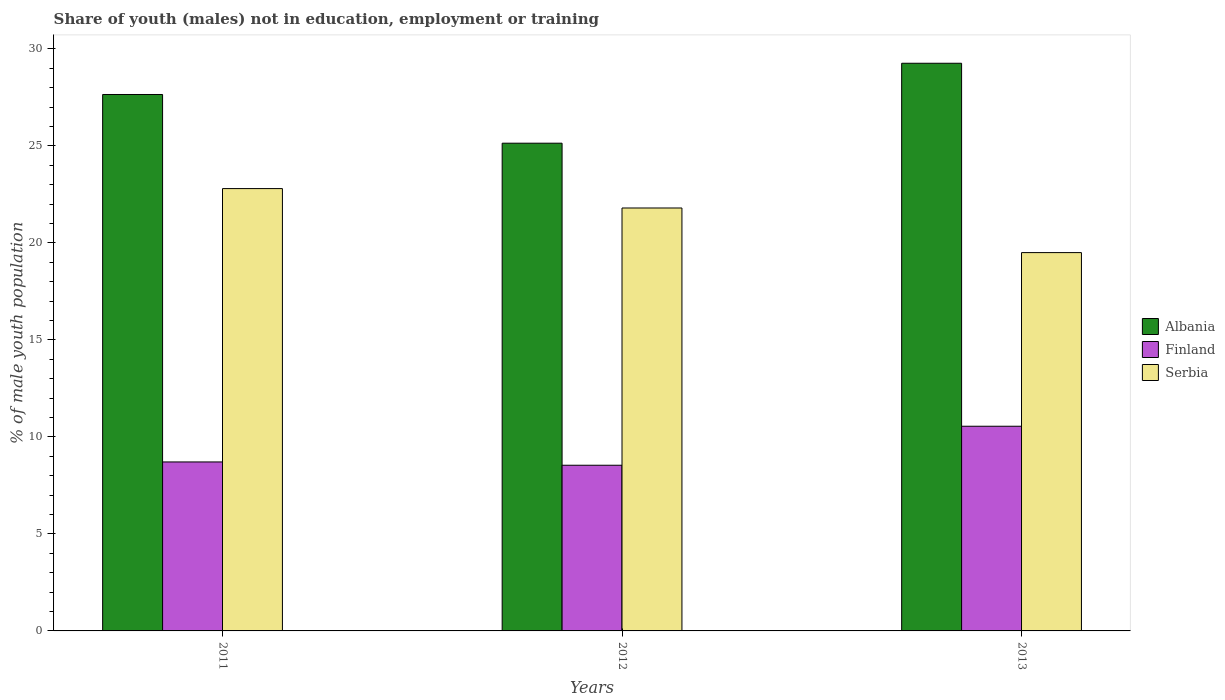How many groups of bars are there?
Make the answer very short. 3. How many bars are there on the 1st tick from the left?
Ensure brevity in your answer.  3. In how many cases, is the number of bars for a given year not equal to the number of legend labels?
Provide a short and direct response. 0. What is the percentage of unemployed males population in in Albania in 2013?
Offer a very short reply. 29.26. Across all years, what is the maximum percentage of unemployed males population in in Albania?
Your answer should be compact. 29.26. Across all years, what is the minimum percentage of unemployed males population in in Albania?
Provide a succinct answer. 25.14. What is the total percentage of unemployed males population in in Serbia in the graph?
Your answer should be very brief. 64.1. What is the difference between the percentage of unemployed males population in in Serbia in 2012 and that in 2013?
Offer a terse response. 2.3. What is the difference between the percentage of unemployed males population in in Albania in 2011 and the percentage of unemployed males population in in Finland in 2013?
Ensure brevity in your answer.  17.1. What is the average percentage of unemployed males population in in Serbia per year?
Ensure brevity in your answer.  21.37. In the year 2012, what is the difference between the percentage of unemployed males population in in Serbia and percentage of unemployed males population in in Finland?
Offer a very short reply. 13.26. What is the ratio of the percentage of unemployed males population in in Finland in 2012 to that in 2013?
Your answer should be very brief. 0.81. Is the percentage of unemployed males population in in Serbia in 2011 less than that in 2013?
Offer a terse response. No. What is the difference between the highest and the second highest percentage of unemployed males population in in Albania?
Your answer should be very brief. 1.61. What is the difference between the highest and the lowest percentage of unemployed males population in in Finland?
Keep it short and to the point. 2.01. Is the sum of the percentage of unemployed males population in in Serbia in 2011 and 2013 greater than the maximum percentage of unemployed males population in in Finland across all years?
Your answer should be compact. Yes. What does the 1st bar from the left in 2012 represents?
Give a very brief answer. Albania. What does the 1st bar from the right in 2013 represents?
Make the answer very short. Serbia. Is it the case that in every year, the sum of the percentage of unemployed males population in in Serbia and percentage of unemployed males population in in Finland is greater than the percentage of unemployed males population in in Albania?
Make the answer very short. Yes. Does the graph contain any zero values?
Your answer should be very brief. No. Does the graph contain grids?
Offer a very short reply. No. How many legend labels are there?
Provide a succinct answer. 3. What is the title of the graph?
Your answer should be very brief. Share of youth (males) not in education, employment or training. Does "Chile" appear as one of the legend labels in the graph?
Provide a succinct answer. No. What is the label or title of the Y-axis?
Your answer should be compact. % of male youth population. What is the % of male youth population of Albania in 2011?
Ensure brevity in your answer.  27.65. What is the % of male youth population in Finland in 2011?
Your response must be concise. 8.71. What is the % of male youth population in Serbia in 2011?
Keep it short and to the point. 22.8. What is the % of male youth population of Albania in 2012?
Offer a terse response. 25.14. What is the % of male youth population of Finland in 2012?
Keep it short and to the point. 8.54. What is the % of male youth population in Serbia in 2012?
Your response must be concise. 21.8. What is the % of male youth population of Albania in 2013?
Your answer should be very brief. 29.26. What is the % of male youth population in Finland in 2013?
Offer a terse response. 10.55. What is the % of male youth population in Serbia in 2013?
Ensure brevity in your answer.  19.5. Across all years, what is the maximum % of male youth population in Albania?
Keep it short and to the point. 29.26. Across all years, what is the maximum % of male youth population in Finland?
Provide a short and direct response. 10.55. Across all years, what is the maximum % of male youth population in Serbia?
Offer a very short reply. 22.8. Across all years, what is the minimum % of male youth population of Albania?
Provide a succinct answer. 25.14. Across all years, what is the minimum % of male youth population in Finland?
Your answer should be compact. 8.54. What is the total % of male youth population of Albania in the graph?
Keep it short and to the point. 82.05. What is the total % of male youth population of Finland in the graph?
Provide a short and direct response. 27.8. What is the total % of male youth population in Serbia in the graph?
Provide a short and direct response. 64.1. What is the difference between the % of male youth population in Albania in 2011 and that in 2012?
Your response must be concise. 2.51. What is the difference between the % of male youth population in Finland in 2011 and that in 2012?
Offer a terse response. 0.17. What is the difference between the % of male youth population of Albania in 2011 and that in 2013?
Your response must be concise. -1.61. What is the difference between the % of male youth population of Finland in 2011 and that in 2013?
Provide a short and direct response. -1.84. What is the difference between the % of male youth population in Serbia in 2011 and that in 2013?
Give a very brief answer. 3.3. What is the difference between the % of male youth population in Albania in 2012 and that in 2013?
Make the answer very short. -4.12. What is the difference between the % of male youth population in Finland in 2012 and that in 2013?
Ensure brevity in your answer.  -2.01. What is the difference between the % of male youth population of Albania in 2011 and the % of male youth population of Finland in 2012?
Your response must be concise. 19.11. What is the difference between the % of male youth population of Albania in 2011 and the % of male youth population of Serbia in 2012?
Keep it short and to the point. 5.85. What is the difference between the % of male youth population of Finland in 2011 and the % of male youth population of Serbia in 2012?
Your response must be concise. -13.09. What is the difference between the % of male youth population in Albania in 2011 and the % of male youth population in Serbia in 2013?
Offer a very short reply. 8.15. What is the difference between the % of male youth population in Finland in 2011 and the % of male youth population in Serbia in 2013?
Keep it short and to the point. -10.79. What is the difference between the % of male youth population in Albania in 2012 and the % of male youth population in Finland in 2013?
Make the answer very short. 14.59. What is the difference between the % of male youth population in Albania in 2012 and the % of male youth population in Serbia in 2013?
Offer a terse response. 5.64. What is the difference between the % of male youth population of Finland in 2012 and the % of male youth population of Serbia in 2013?
Provide a succinct answer. -10.96. What is the average % of male youth population in Albania per year?
Your response must be concise. 27.35. What is the average % of male youth population of Finland per year?
Make the answer very short. 9.27. What is the average % of male youth population in Serbia per year?
Offer a very short reply. 21.37. In the year 2011, what is the difference between the % of male youth population in Albania and % of male youth population in Finland?
Keep it short and to the point. 18.94. In the year 2011, what is the difference between the % of male youth population in Albania and % of male youth population in Serbia?
Give a very brief answer. 4.85. In the year 2011, what is the difference between the % of male youth population in Finland and % of male youth population in Serbia?
Provide a short and direct response. -14.09. In the year 2012, what is the difference between the % of male youth population of Albania and % of male youth population of Finland?
Ensure brevity in your answer.  16.6. In the year 2012, what is the difference between the % of male youth population of Albania and % of male youth population of Serbia?
Provide a succinct answer. 3.34. In the year 2012, what is the difference between the % of male youth population in Finland and % of male youth population in Serbia?
Provide a short and direct response. -13.26. In the year 2013, what is the difference between the % of male youth population in Albania and % of male youth population in Finland?
Offer a terse response. 18.71. In the year 2013, what is the difference between the % of male youth population in Albania and % of male youth population in Serbia?
Offer a very short reply. 9.76. In the year 2013, what is the difference between the % of male youth population in Finland and % of male youth population in Serbia?
Your answer should be compact. -8.95. What is the ratio of the % of male youth population in Albania in 2011 to that in 2012?
Keep it short and to the point. 1.1. What is the ratio of the % of male youth population in Finland in 2011 to that in 2012?
Offer a terse response. 1.02. What is the ratio of the % of male youth population in Serbia in 2011 to that in 2012?
Keep it short and to the point. 1.05. What is the ratio of the % of male youth population in Albania in 2011 to that in 2013?
Your response must be concise. 0.94. What is the ratio of the % of male youth population in Finland in 2011 to that in 2013?
Keep it short and to the point. 0.83. What is the ratio of the % of male youth population of Serbia in 2011 to that in 2013?
Keep it short and to the point. 1.17. What is the ratio of the % of male youth population of Albania in 2012 to that in 2013?
Your answer should be very brief. 0.86. What is the ratio of the % of male youth population in Finland in 2012 to that in 2013?
Your response must be concise. 0.81. What is the ratio of the % of male youth population of Serbia in 2012 to that in 2013?
Your response must be concise. 1.12. What is the difference between the highest and the second highest % of male youth population of Albania?
Your answer should be very brief. 1.61. What is the difference between the highest and the second highest % of male youth population of Finland?
Offer a very short reply. 1.84. What is the difference between the highest and the lowest % of male youth population of Albania?
Your answer should be compact. 4.12. What is the difference between the highest and the lowest % of male youth population of Finland?
Offer a very short reply. 2.01. 